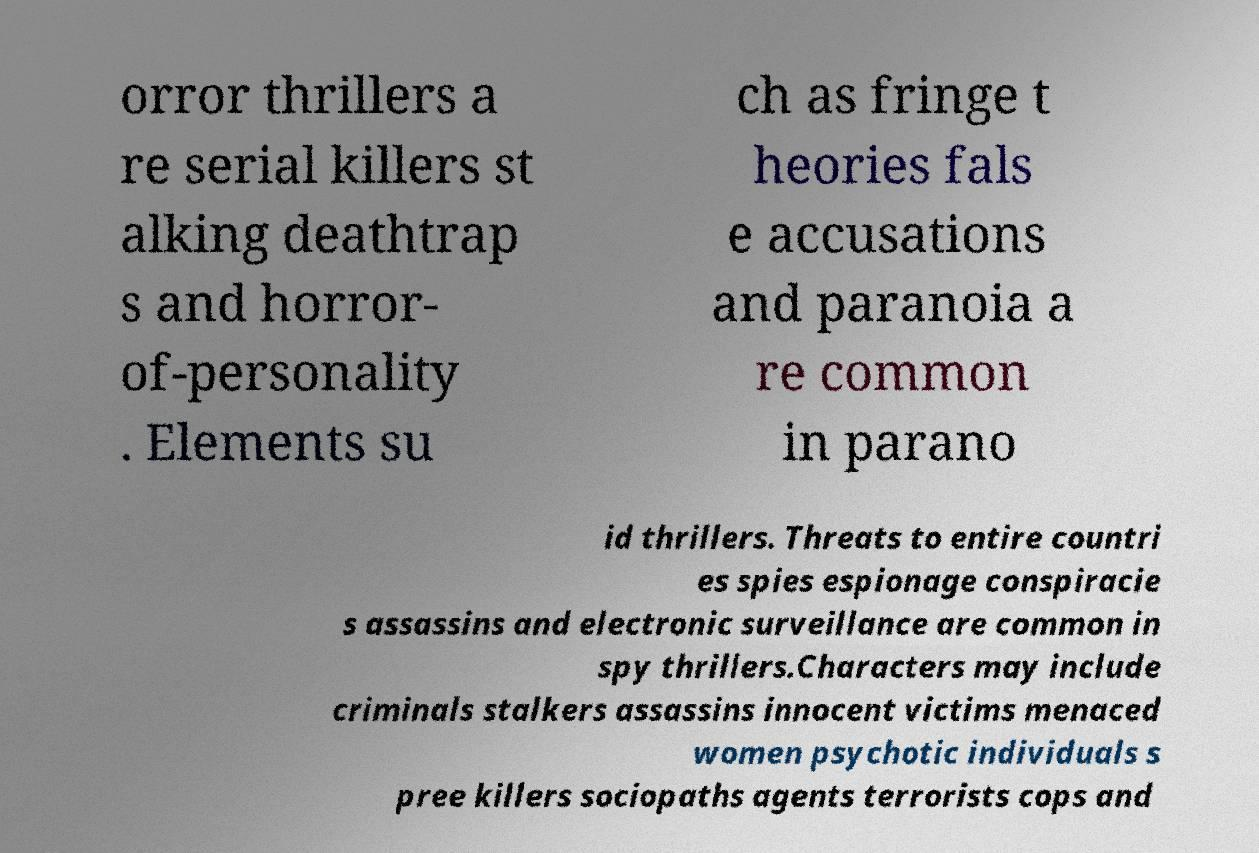Can you read and provide the text displayed in the image?This photo seems to have some interesting text. Can you extract and type it out for me? orror thrillers a re serial killers st alking deathtrap s and horror- of-personality . Elements su ch as fringe t heories fals e accusations and paranoia a re common in parano id thrillers. Threats to entire countri es spies espionage conspiracie s assassins and electronic surveillance are common in spy thrillers.Characters may include criminals stalkers assassins innocent victims menaced women psychotic individuals s pree killers sociopaths agents terrorists cops and 